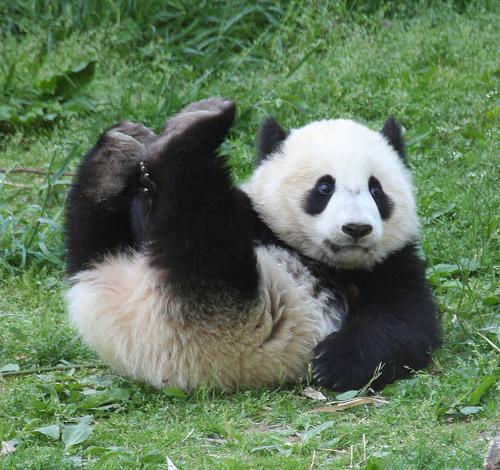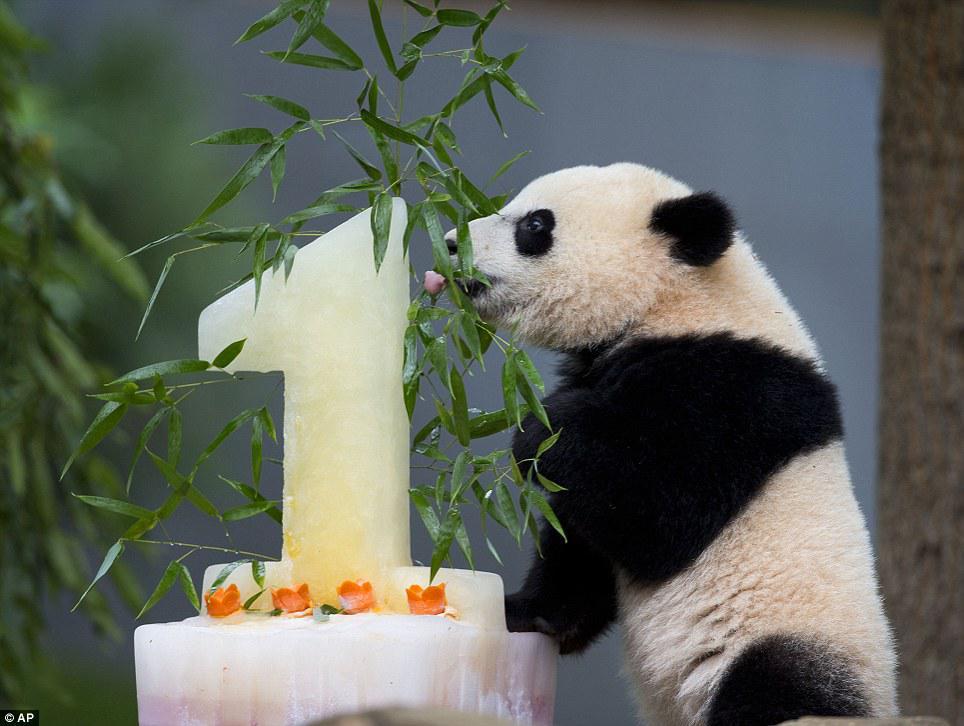The first image is the image on the left, the second image is the image on the right. Assess this claim about the two images: "A panda is laying on its back.". Correct or not? Answer yes or no. Yes. The first image is the image on the left, the second image is the image on the right. For the images displayed, is the sentence "The left and right image contains the same number of pandas." factually correct? Answer yes or no. Yes. 